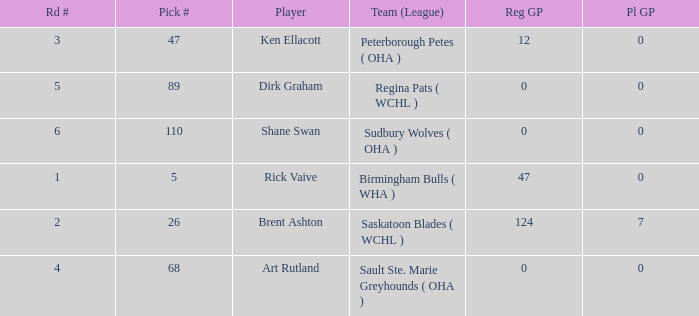How many reg GP for rick vaive in round 1? None. 